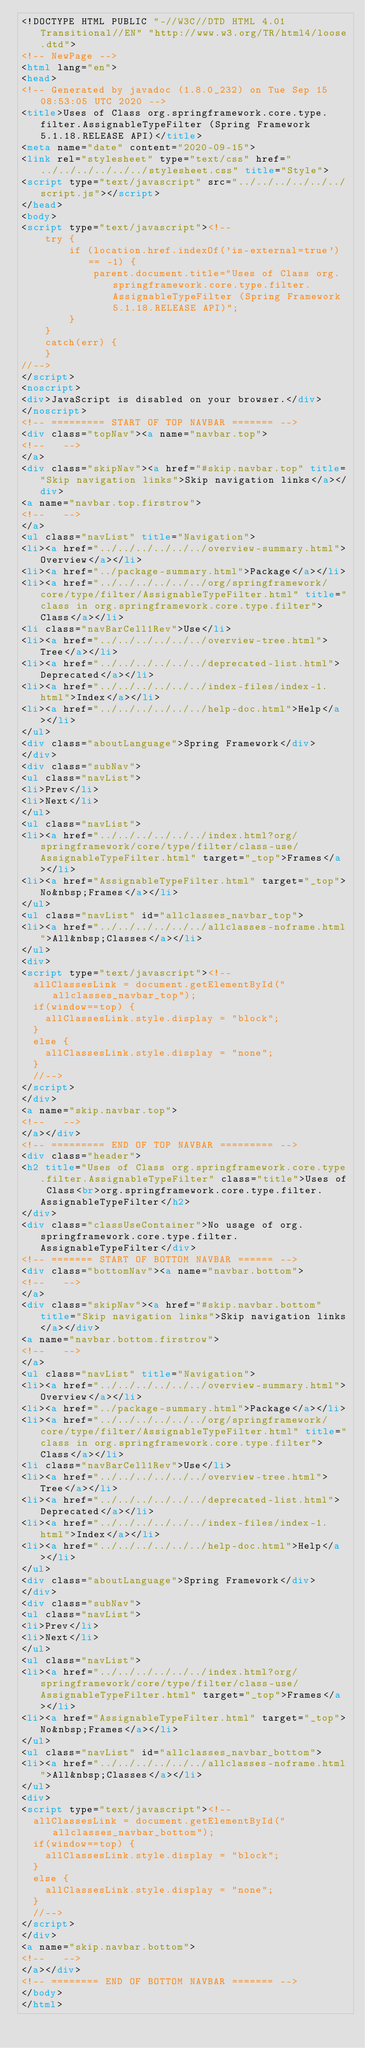<code> <loc_0><loc_0><loc_500><loc_500><_HTML_><!DOCTYPE HTML PUBLIC "-//W3C//DTD HTML 4.01 Transitional//EN" "http://www.w3.org/TR/html4/loose.dtd">
<!-- NewPage -->
<html lang="en">
<head>
<!-- Generated by javadoc (1.8.0_232) on Tue Sep 15 08:53:05 UTC 2020 -->
<title>Uses of Class org.springframework.core.type.filter.AssignableTypeFilter (Spring Framework 5.1.18.RELEASE API)</title>
<meta name="date" content="2020-09-15">
<link rel="stylesheet" type="text/css" href="../../../../../../stylesheet.css" title="Style">
<script type="text/javascript" src="../../../../../../script.js"></script>
</head>
<body>
<script type="text/javascript"><!--
    try {
        if (location.href.indexOf('is-external=true') == -1) {
            parent.document.title="Uses of Class org.springframework.core.type.filter.AssignableTypeFilter (Spring Framework 5.1.18.RELEASE API)";
        }
    }
    catch(err) {
    }
//-->
</script>
<noscript>
<div>JavaScript is disabled on your browser.</div>
</noscript>
<!-- ========= START OF TOP NAVBAR ======= -->
<div class="topNav"><a name="navbar.top">
<!--   -->
</a>
<div class="skipNav"><a href="#skip.navbar.top" title="Skip navigation links">Skip navigation links</a></div>
<a name="navbar.top.firstrow">
<!--   -->
</a>
<ul class="navList" title="Navigation">
<li><a href="../../../../../../overview-summary.html">Overview</a></li>
<li><a href="../package-summary.html">Package</a></li>
<li><a href="../../../../../../org/springframework/core/type/filter/AssignableTypeFilter.html" title="class in org.springframework.core.type.filter">Class</a></li>
<li class="navBarCell1Rev">Use</li>
<li><a href="../../../../../../overview-tree.html">Tree</a></li>
<li><a href="../../../../../../deprecated-list.html">Deprecated</a></li>
<li><a href="../../../../../../index-files/index-1.html">Index</a></li>
<li><a href="../../../../../../help-doc.html">Help</a></li>
</ul>
<div class="aboutLanguage">Spring Framework</div>
</div>
<div class="subNav">
<ul class="navList">
<li>Prev</li>
<li>Next</li>
</ul>
<ul class="navList">
<li><a href="../../../../../../index.html?org/springframework/core/type/filter/class-use/AssignableTypeFilter.html" target="_top">Frames</a></li>
<li><a href="AssignableTypeFilter.html" target="_top">No&nbsp;Frames</a></li>
</ul>
<ul class="navList" id="allclasses_navbar_top">
<li><a href="../../../../../../allclasses-noframe.html">All&nbsp;Classes</a></li>
</ul>
<div>
<script type="text/javascript"><!--
  allClassesLink = document.getElementById("allclasses_navbar_top");
  if(window==top) {
    allClassesLink.style.display = "block";
  }
  else {
    allClassesLink.style.display = "none";
  }
  //-->
</script>
</div>
<a name="skip.navbar.top">
<!--   -->
</a></div>
<!-- ========= END OF TOP NAVBAR ========= -->
<div class="header">
<h2 title="Uses of Class org.springframework.core.type.filter.AssignableTypeFilter" class="title">Uses of Class<br>org.springframework.core.type.filter.AssignableTypeFilter</h2>
</div>
<div class="classUseContainer">No usage of org.springframework.core.type.filter.AssignableTypeFilter</div>
<!-- ======= START OF BOTTOM NAVBAR ====== -->
<div class="bottomNav"><a name="navbar.bottom">
<!--   -->
</a>
<div class="skipNav"><a href="#skip.navbar.bottom" title="Skip navigation links">Skip navigation links</a></div>
<a name="navbar.bottom.firstrow">
<!--   -->
</a>
<ul class="navList" title="Navigation">
<li><a href="../../../../../../overview-summary.html">Overview</a></li>
<li><a href="../package-summary.html">Package</a></li>
<li><a href="../../../../../../org/springframework/core/type/filter/AssignableTypeFilter.html" title="class in org.springframework.core.type.filter">Class</a></li>
<li class="navBarCell1Rev">Use</li>
<li><a href="../../../../../../overview-tree.html">Tree</a></li>
<li><a href="../../../../../../deprecated-list.html">Deprecated</a></li>
<li><a href="../../../../../../index-files/index-1.html">Index</a></li>
<li><a href="../../../../../../help-doc.html">Help</a></li>
</ul>
<div class="aboutLanguage">Spring Framework</div>
</div>
<div class="subNav">
<ul class="navList">
<li>Prev</li>
<li>Next</li>
</ul>
<ul class="navList">
<li><a href="../../../../../../index.html?org/springframework/core/type/filter/class-use/AssignableTypeFilter.html" target="_top">Frames</a></li>
<li><a href="AssignableTypeFilter.html" target="_top">No&nbsp;Frames</a></li>
</ul>
<ul class="navList" id="allclasses_navbar_bottom">
<li><a href="../../../../../../allclasses-noframe.html">All&nbsp;Classes</a></li>
</ul>
<div>
<script type="text/javascript"><!--
  allClassesLink = document.getElementById("allclasses_navbar_bottom");
  if(window==top) {
    allClassesLink.style.display = "block";
  }
  else {
    allClassesLink.style.display = "none";
  }
  //-->
</script>
</div>
<a name="skip.navbar.bottom">
<!--   -->
</a></div>
<!-- ======== END OF BOTTOM NAVBAR ======= -->
</body>
</html>
</code> 